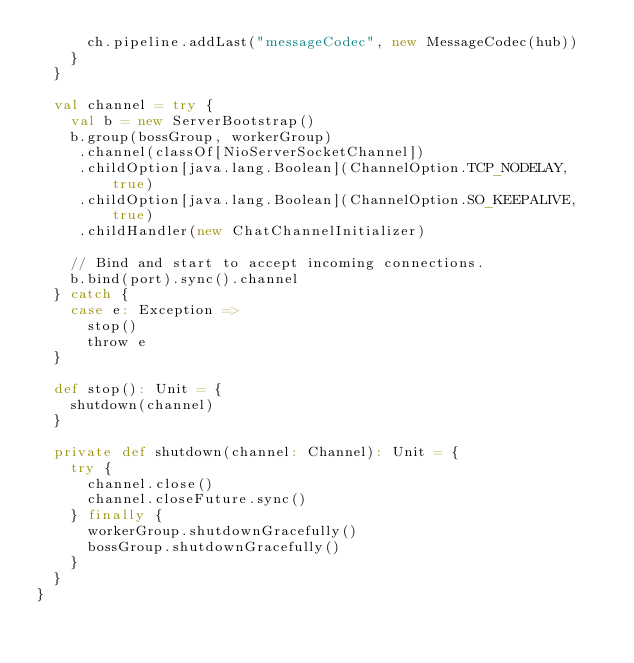<code> <loc_0><loc_0><loc_500><loc_500><_Scala_>      ch.pipeline.addLast("messageCodec", new MessageCodec(hub))
    }
  }

  val channel = try {
    val b = new ServerBootstrap()
    b.group(bossGroup, workerGroup)
     .channel(classOf[NioServerSocketChannel])
     .childOption[java.lang.Boolean](ChannelOption.TCP_NODELAY, true)
     .childOption[java.lang.Boolean](ChannelOption.SO_KEEPALIVE, true)
     .childHandler(new ChatChannelInitializer)

    // Bind and start to accept incoming connections.
    b.bind(port).sync().channel
  } catch {
    case e: Exception =>
      stop()
      throw e
  }
  
  def stop(): Unit = {
    shutdown(channel)
  }

  private def shutdown(channel: Channel): Unit = {
    try {
      channel.close()
      channel.closeFuture.sync()
    } finally {
      workerGroup.shutdownGracefully()
      bossGroup.shutdownGracefully()
    }
  }
}
</code> 